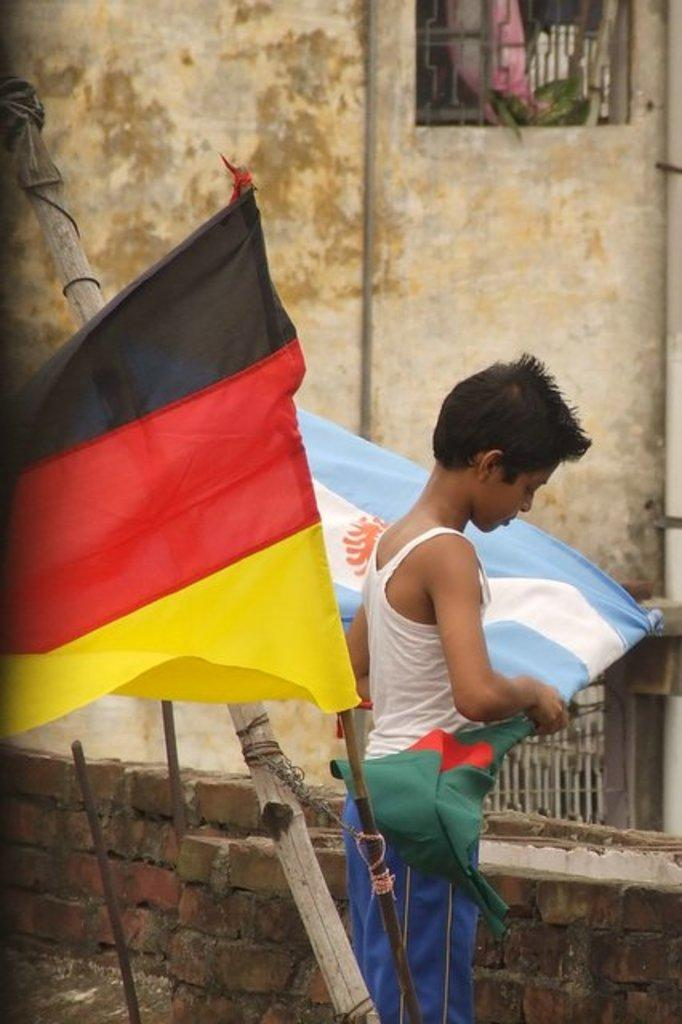Who is the main subject in the image? There is a boy in the image. What is the boy holding in the image? The boy is holding a flag. Can you describe the other flag in the image? There is another flag tied to a wooden pole. What can be seen in the background of the image? There is a brick wall and the side wall of a house in the background of the image. What type of apple is the boy eating in the image? There is no apple present in the image; the boy is holding a flag. What is the relation between the boy and the person holding the other flag? There is no information about any other person holding a flag or their relation to the boy in the image. 